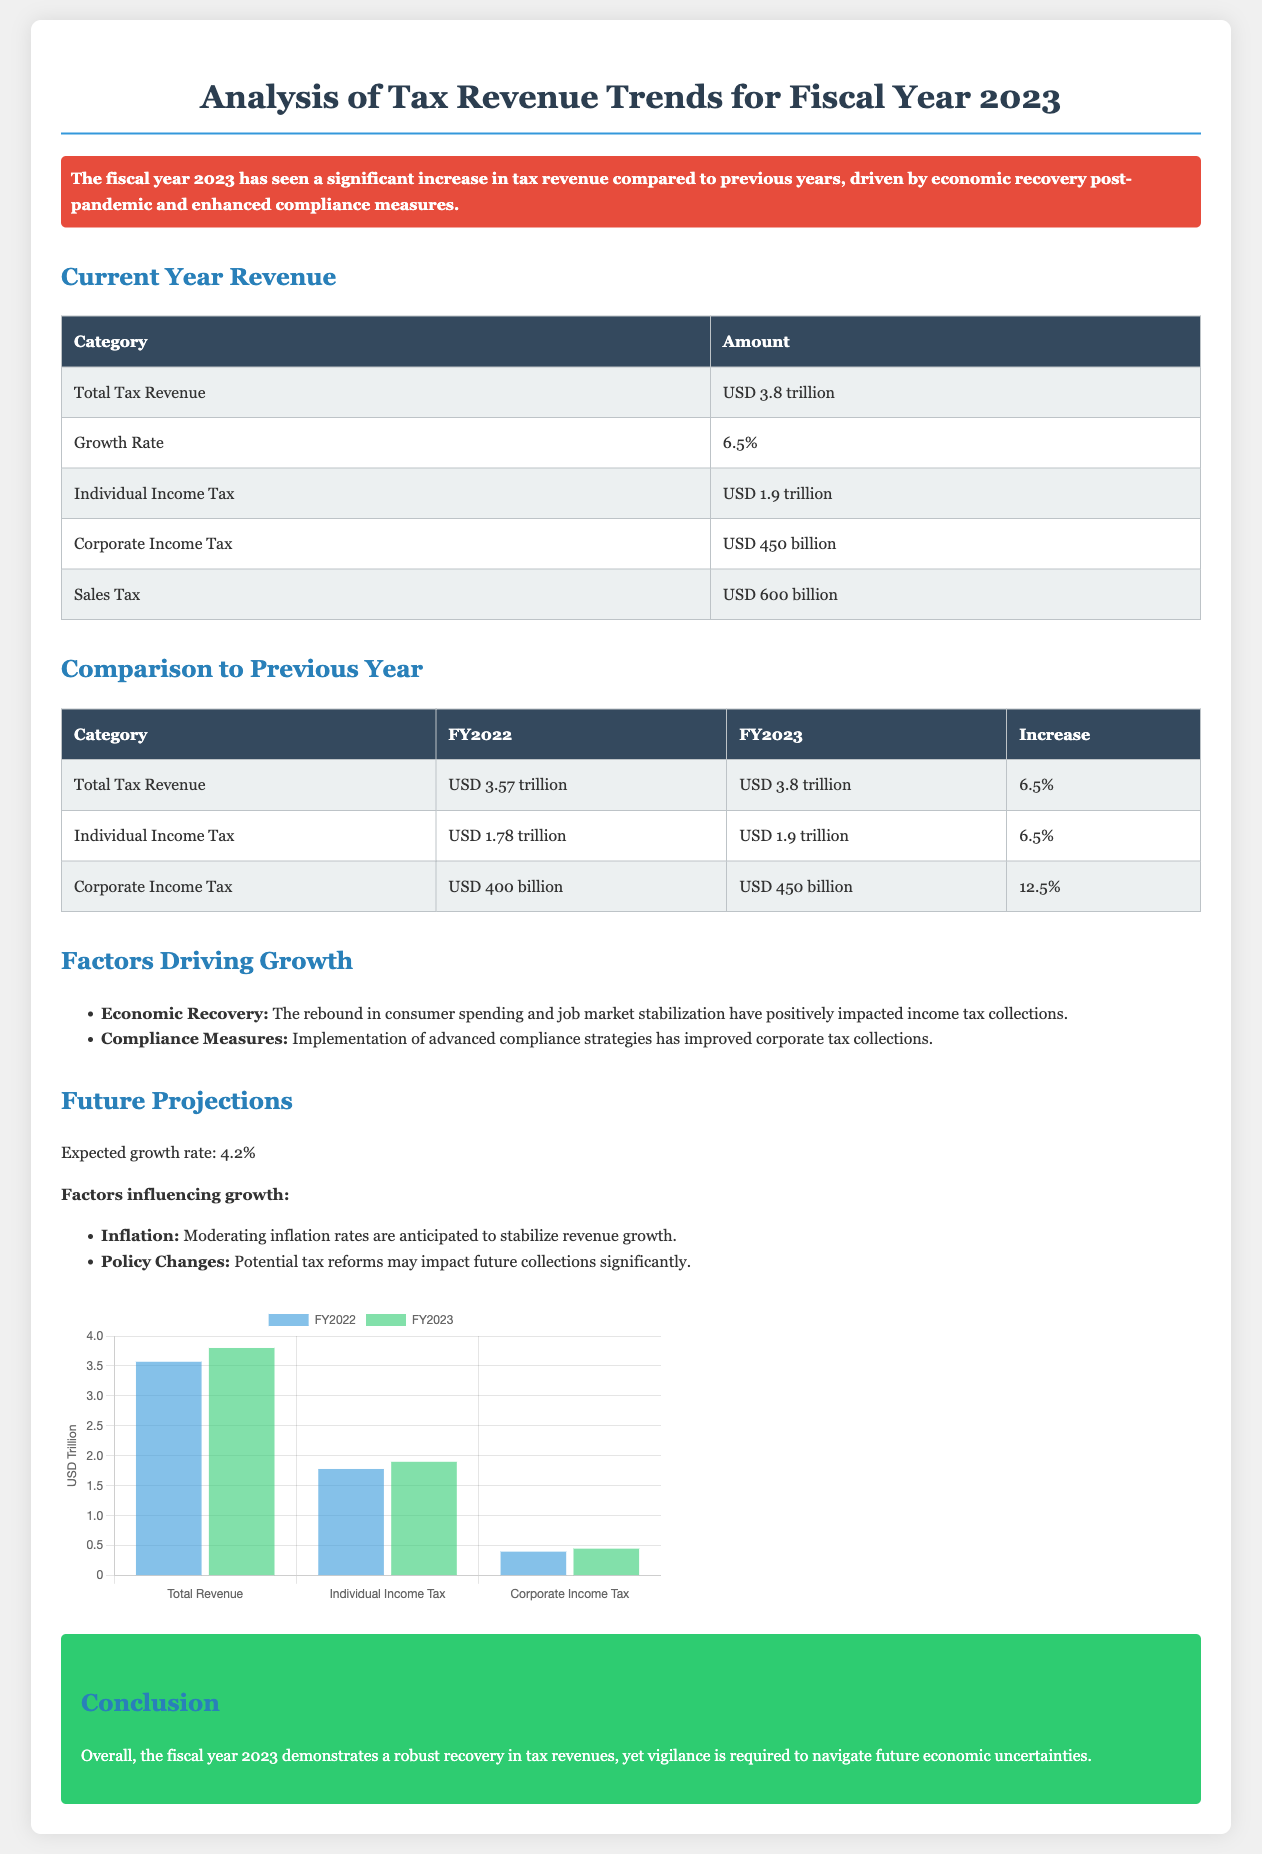What is the total tax revenue for FY2023? The total tax revenue for FY2023 is specified in the document as USD 3.8 trillion.
Answer: USD 3.8 trillion What is the growth rate of tax revenue for FY2023? The growth rate is mentioned in the current year revenue section as 6.5%.
Answer: 6.5% How much revenue was collected from Individual Income Tax in FY2023? The document states that Individual Income Tax revenue for FY2023 is USD 1.9 trillion.
Answer: USD 1.9 trillion What was the Corporate Income Tax amount in FY2022? The Corporate Income Tax amount for FY2022 is provided in the comparison table as USD 400 billion.
Answer: USD 400 billion What are two factors driving the growth of tax revenue in FY2023? The highlighted factors from the document include Economic Recovery and Compliance Measures.
Answer: Economic Recovery, Compliance Measures What is the expected growth rate for future tax revenue? The document projects the future growth rate as 4.2%.
Answer: 4.2% Which tax category saw the highest percentage increase from FY2022 to FY2023? The category with the highest percentage increase is Corporate Income Tax, increasing by 12.5%.
Answer: Corporate Income Tax What colors are used in the revenue chart for FY2022 and FY2023? FY2022 is represented with a blue color and FY2023 with green color in the chart.
Answer: Blue, Green What conclusion is drawn about the tax revenues in FY2023? The document concludes that there is a robust recovery in tax revenues, with a note on the need for vigilance concerning future uncertainties.
Answer: Robust recovery in tax revenues 